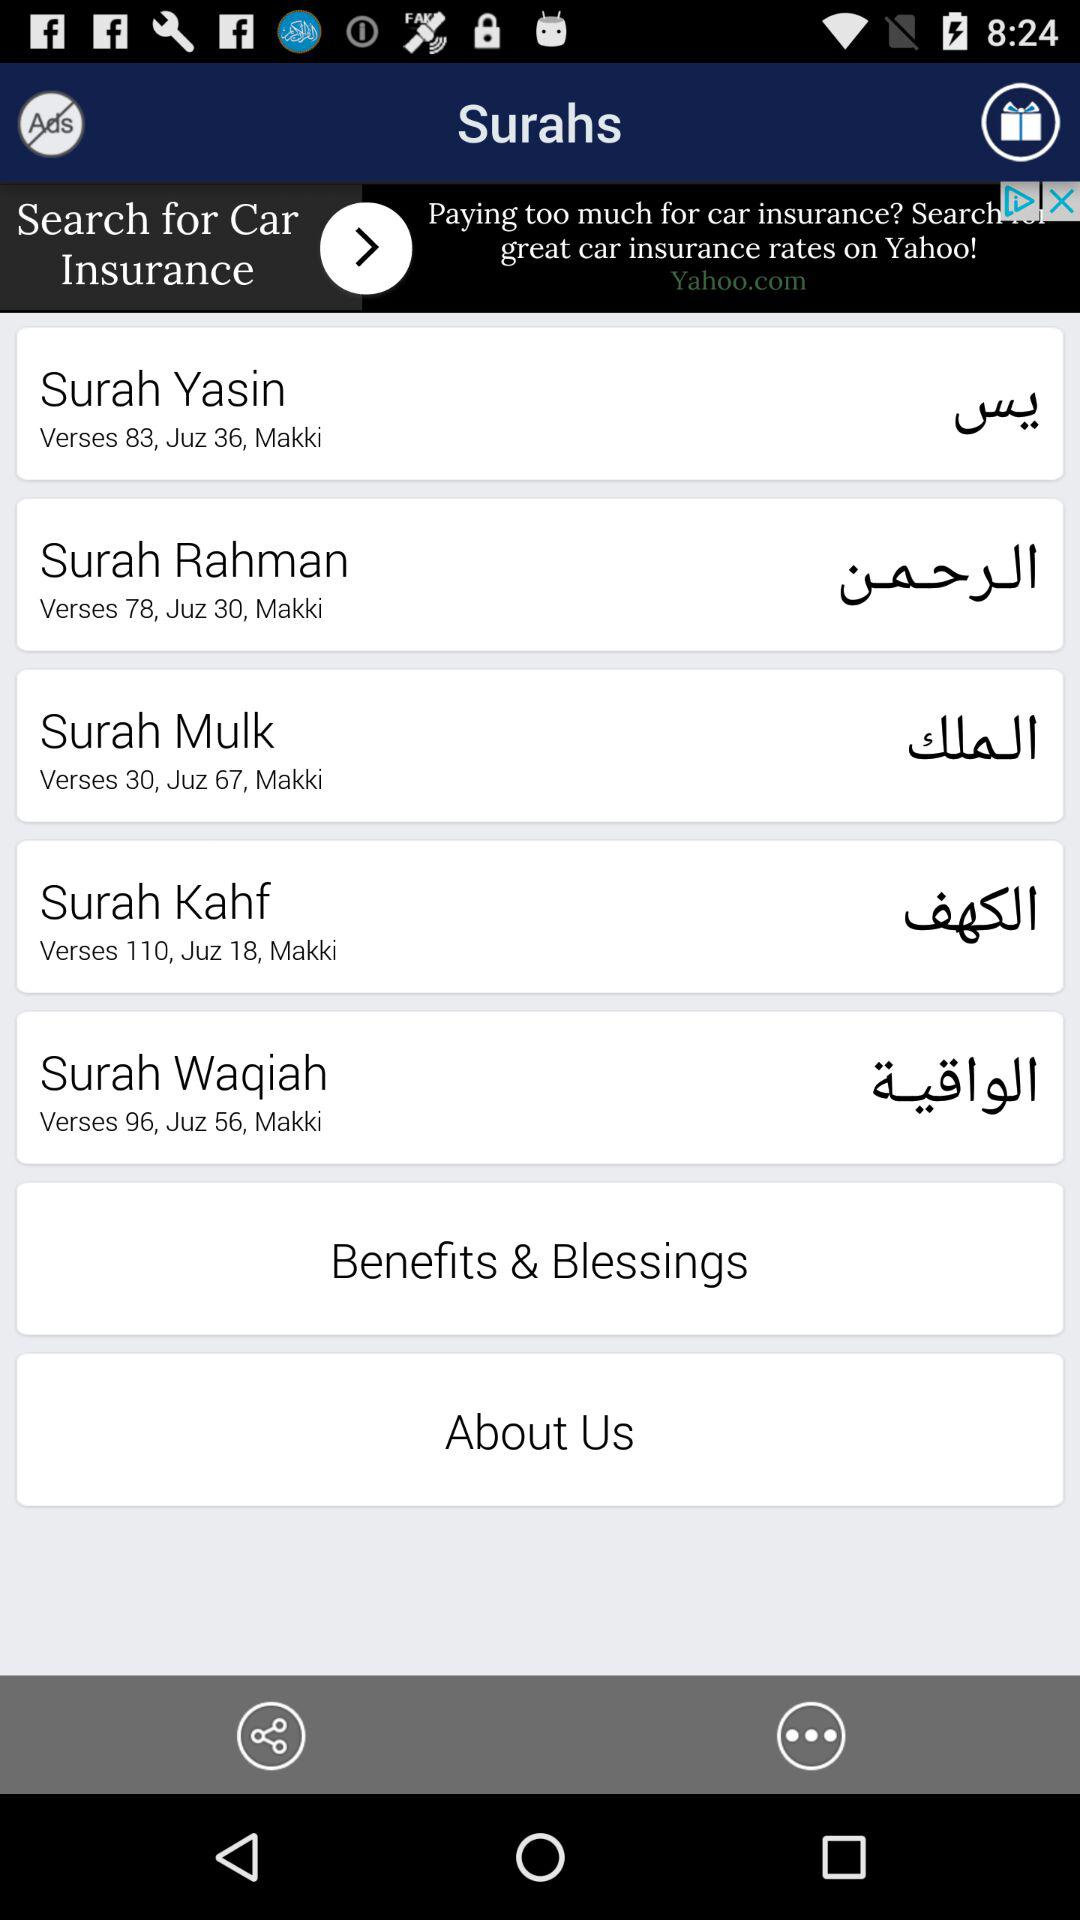How many verses does Surah Yasin have?
Answer the question using a single word or phrase. 83 